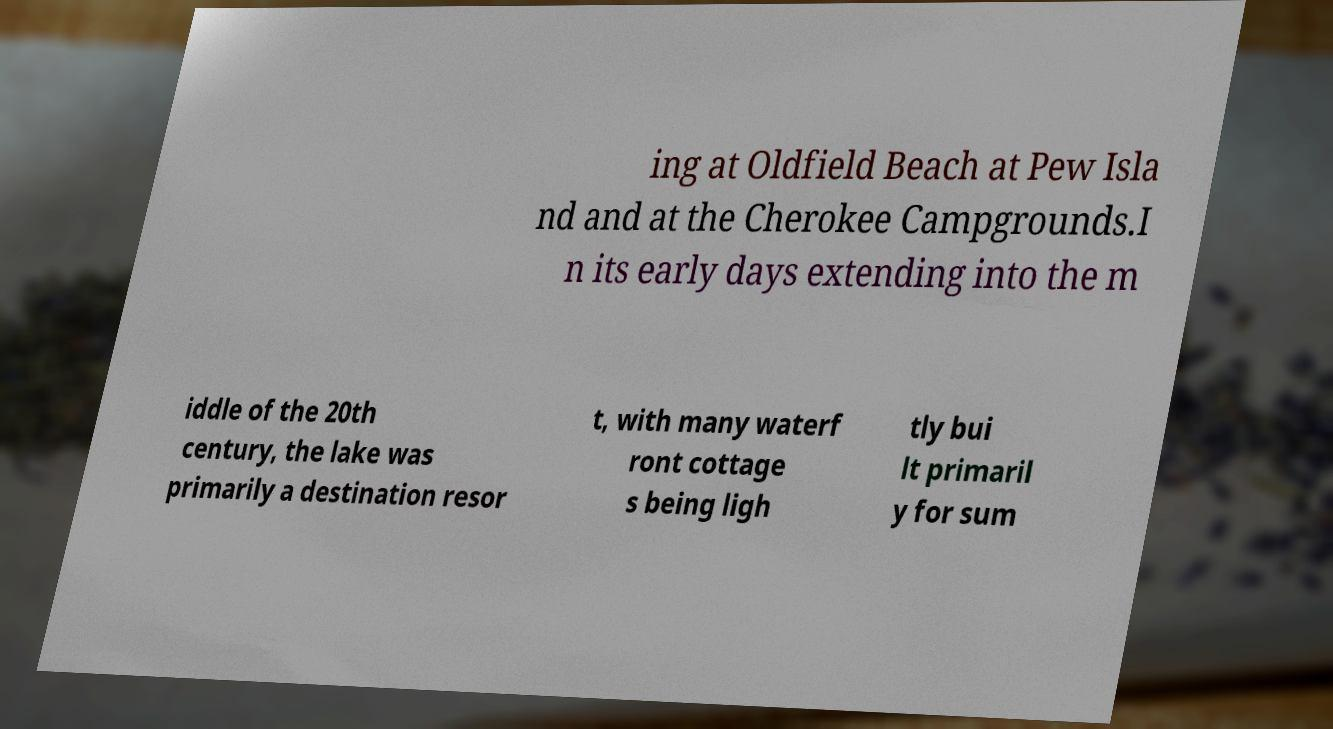There's text embedded in this image that I need extracted. Can you transcribe it verbatim? ing at Oldfield Beach at Pew Isla nd and at the Cherokee Campgrounds.I n its early days extending into the m iddle of the 20th century, the lake was primarily a destination resor t, with many waterf ront cottage s being ligh tly bui lt primaril y for sum 